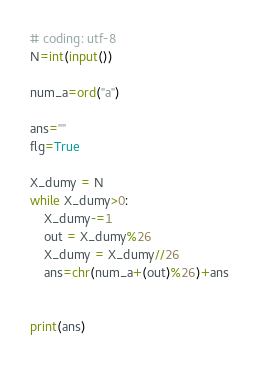<code> <loc_0><loc_0><loc_500><loc_500><_Python_># coding: utf-8
N=int(input())

num_a=ord("a")

ans=""
flg=True

X_dumy = N
while X_dumy>0:
    X_dumy-=1
    out = X_dumy%26
    X_dumy = X_dumy//26
    ans=chr(num_a+(out)%26)+ans


print(ans)
</code> 